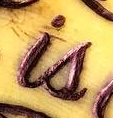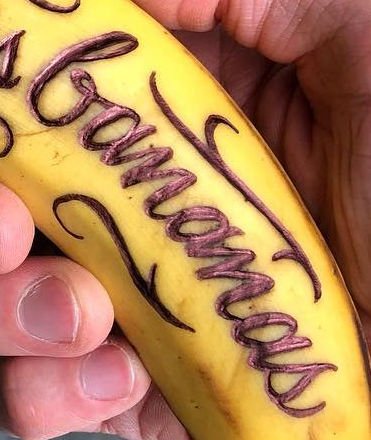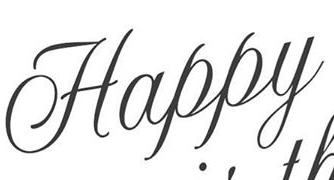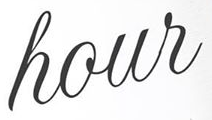What words are shown in these images in order, separated by a semicolon? is; bananas; Happy; hour 